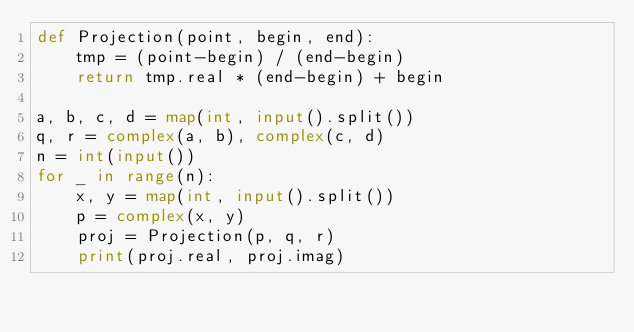<code> <loc_0><loc_0><loc_500><loc_500><_Python_>def Projection(point, begin, end):
	tmp = (point-begin) / (end-begin)
	return tmp.real * (end-begin) + begin

a, b, c, d = map(int, input().split())
q, r = complex(a, b), complex(c, d)
n = int(input())
for _ in range(n):
	x, y = map(int, input().split())
	p = complex(x, y)
	proj = Projection(p, q, r)
	print(proj.real, proj.imag)
</code> 